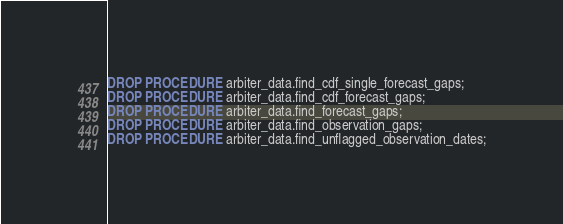Convert code to text. <code><loc_0><loc_0><loc_500><loc_500><_SQL_>DROP PROCEDURE arbiter_data.find_cdf_single_forecast_gaps;
DROP PROCEDURE arbiter_data.find_cdf_forecast_gaps;
DROP PROCEDURE arbiter_data.find_forecast_gaps;
DROP PROCEDURE arbiter_data.find_observation_gaps;
DROP PROCEDURE arbiter_data.find_unflagged_observation_dates;
</code> 